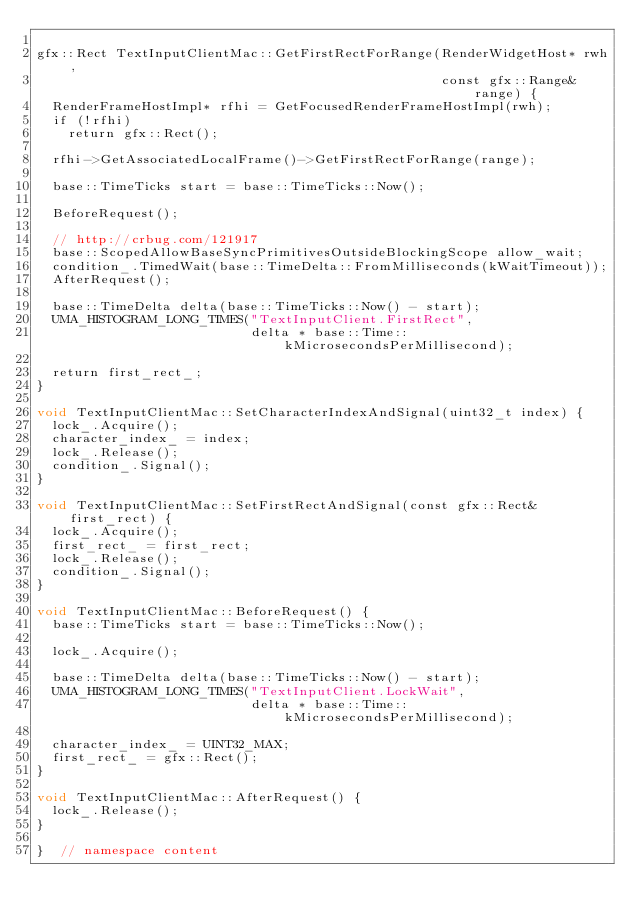Convert code to text. <code><loc_0><loc_0><loc_500><loc_500><_ObjectiveC_>
gfx::Rect TextInputClientMac::GetFirstRectForRange(RenderWidgetHost* rwh,
                                                   const gfx::Range& range) {
  RenderFrameHostImpl* rfhi = GetFocusedRenderFrameHostImpl(rwh);
  if (!rfhi)
    return gfx::Rect();

  rfhi->GetAssociatedLocalFrame()->GetFirstRectForRange(range);

  base::TimeTicks start = base::TimeTicks::Now();

  BeforeRequest();

  // http://crbug.com/121917
  base::ScopedAllowBaseSyncPrimitivesOutsideBlockingScope allow_wait;
  condition_.TimedWait(base::TimeDelta::FromMilliseconds(kWaitTimeout));
  AfterRequest();

  base::TimeDelta delta(base::TimeTicks::Now() - start);
  UMA_HISTOGRAM_LONG_TIMES("TextInputClient.FirstRect",
                           delta * base::Time::kMicrosecondsPerMillisecond);

  return first_rect_;
}

void TextInputClientMac::SetCharacterIndexAndSignal(uint32_t index) {
  lock_.Acquire();
  character_index_ = index;
  lock_.Release();
  condition_.Signal();
}

void TextInputClientMac::SetFirstRectAndSignal(const gfx::Rect& first_rect) {
  lock_.Acquire();
  first_rect_ = first_rect;
  lock_.Release();
  condition_.Signal();
}

void TextInputClientMac::BeforeRequest() {
  base::TimeTicks start = base::TimeTicks::Now();

  lock_.Acquire();

  base::TimeDelta delta(base::TimeTicks::Now() - start);
  UMA_HISTOGRAM_LONG_TIMES("TextInputClient.LockWait",
                           delta * base::Time::kMicrosecondsPerMillisecond);

  character_index_ = UINT32_MAX;
  first_rect_ = gfx::Rect();
}

void TextInputClientMac::AfterRequest() {
  lock_.Release();
}

}  // namespace content
</code> 